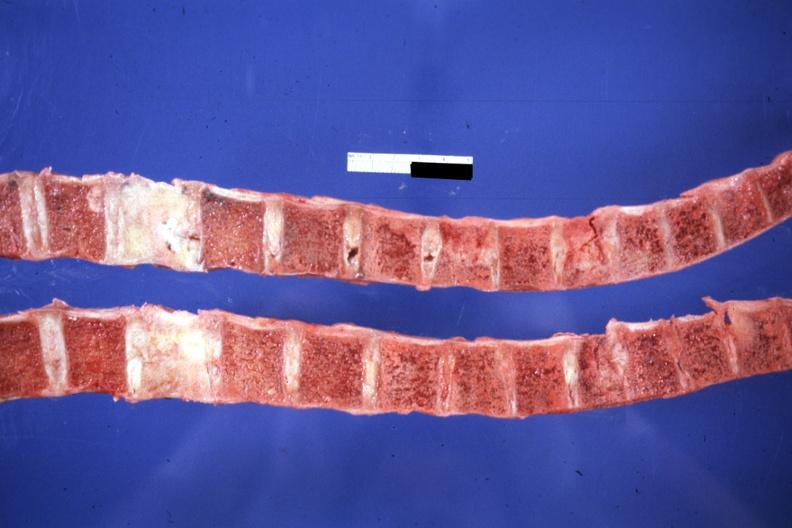what do saggital section typical but probably breast lesion?
Answer the question using a single word or phrase. Not know history 